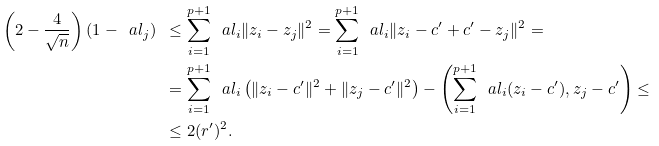<formula> <loc_0><loc_0><loc_500><loc_500>\left ( 2 - \frac { 4 } { \sqrt { n } } \right ) ( 1 - \ a l _ { j } ) \ & \leq \sum _ { i = 1 } ^ { p + 1 } \ \ a l _ { i } \| z _ { i } - z _ { j } \| ^ { 2 } = \sum _ { i = 1 } ^ { p + 1 } \ \ a l _ { i } \| z _ { i } - c ^ { \prime } + c ^ { \prime } - z _ { j } \| ^ { 2 } = \\ & = \sum _ { i = 1 } ^ { p + 1 } \ \ a l _ { i } \left ( \| z _ { i } - c ^ { \prime } \| ^ { 2 } + \| z _ { j } - c ^ { \prime } \| ^ { 2 } \right ) - \left ( \sum _ { i = 1 } ^ { p + 1 } \ \ a l _ { i } ( z _ { i } - c ^ { \prime } ) , z _ { j } - c ^ { \prime } \right ) \leq \\ & \leq 2 ( r ^ { \prime } ) ^ { 2 } .</formula> 